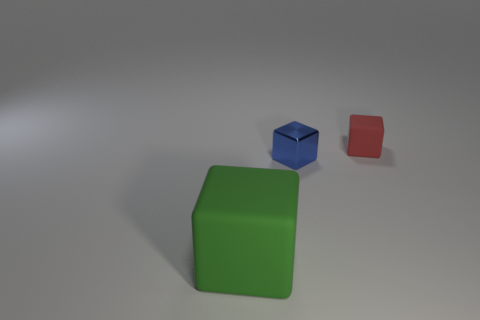Are there any other things that have the same material as the tiny blue object?
Your answer should be very brief. No. What color is the large matte thing?
Ensure brevity in your answer.  Green. Are there any other things that have the same shape as the blue shiny object?
Provide a short and direct response. Yes. There is a metallic thing that is the same shape as the small rubber object; what is its color?
Offer a terse response. Blue. Is the shape of the big green rubber thing the same as the tiny blue thing?
Your answer should be compact. Yes. How many cubes are either green things or small red objects?
Offer a very short reply. 2. What color is the small cube that is the same material as the large object?
Keep it short and to the point. Red. Does the matte cube that is left of the red matte thing have the same size as the tiny red matte block?
Offer a terse response. No. Does the tiny red block have the same material as the tiny object that is in front of the red block?
Ensure brevity in your answer.  No. The matte object that is in front of the small blue cube is what color?
Offer a terse response. Green. 